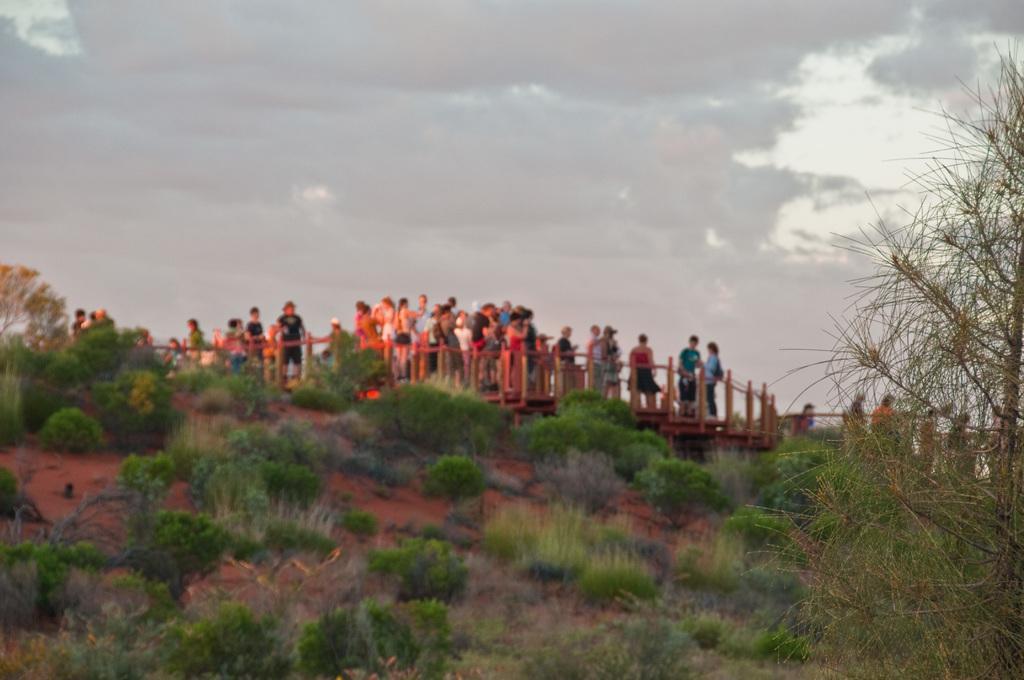Could you give a brief overview of what you see in this image? In this image in front there are plants. In the center of the image there are people standing on the wooden bridge. In the background of the image there is sky and there are trees. 